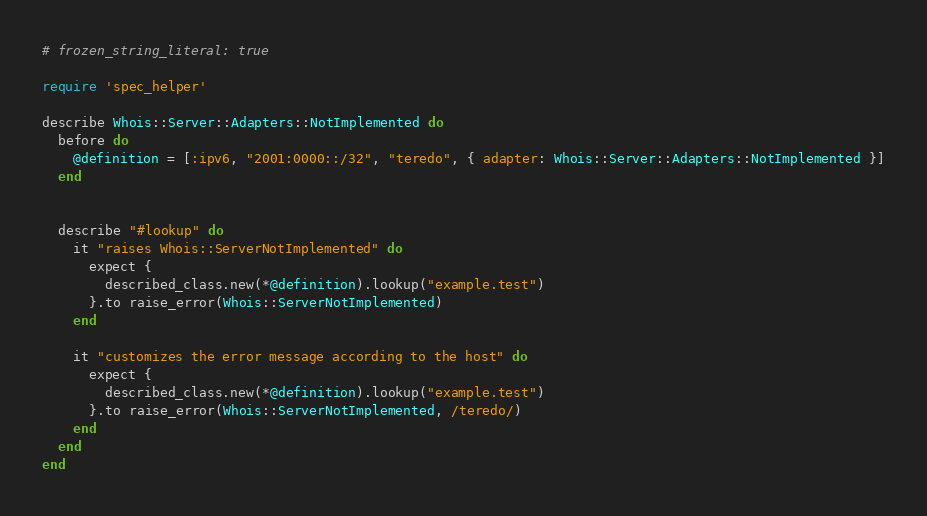Convert code to text. <code><loc_0><loc_0><loc_500><loc_500><_Ruby_># frozen_string_literal: true

require 'spec_helper'

describe Whois::Server::Adapters::NotImplemented do
  before do
    @definition = [:ipv6, "2001:0000::/32", "teredo", { adapter: Whois::Server::Adapters::NotImplemented }]
  end


  describe "#lookup" do
    it "raises Whois::ServerNotImplemented" do
      expect {
        described_class.new(*@definition).lookup("example.test")
      }.to raise_error(Whois::ServerNotImplemented)
    end

    it "customizes the error message according to the host" do
      expect {
        described_class.new(*@definition).lookup("example.test")
      }.to raise_error(Whois::ServerNotImplemented, /teredo/)
    end
  end
end
</code> 